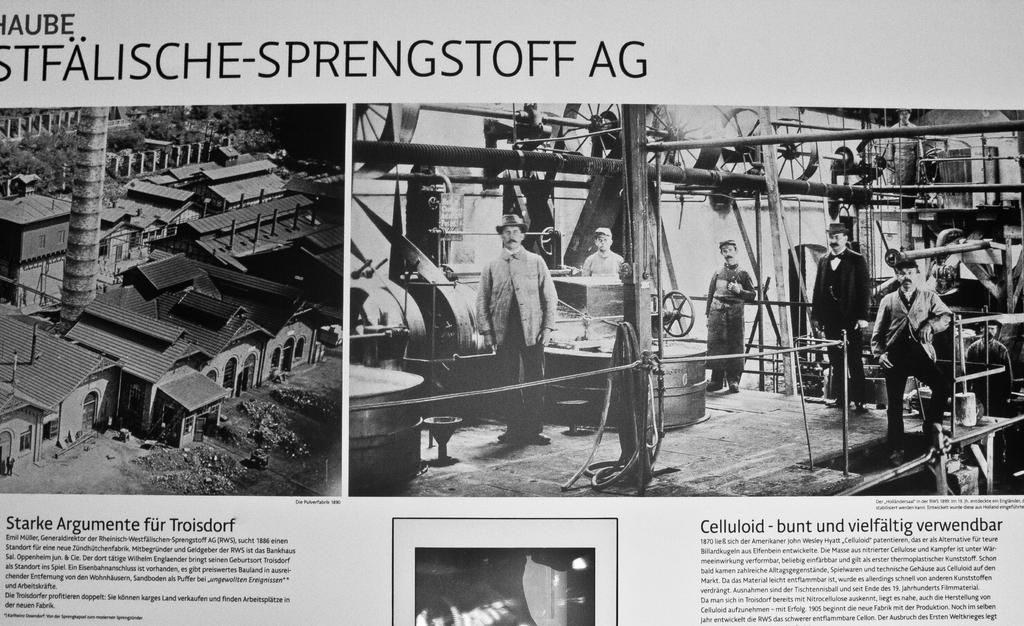What is the main object in the image? There is a newspaper in the image. How many people can be seen in the image? There are many persons visible in the image. What is written at the bottom of the image? There is text at the bottom of the image. What type of structures are on the left side of the image? There are houses on the left side of the image. What is the rate of the boats in the harbor in the image? There is no harbor or boats present in the image; it features a newspaper and houses. What type of cover is on the newspaper in the image? There is no cover visible on the newspaper in the image. 